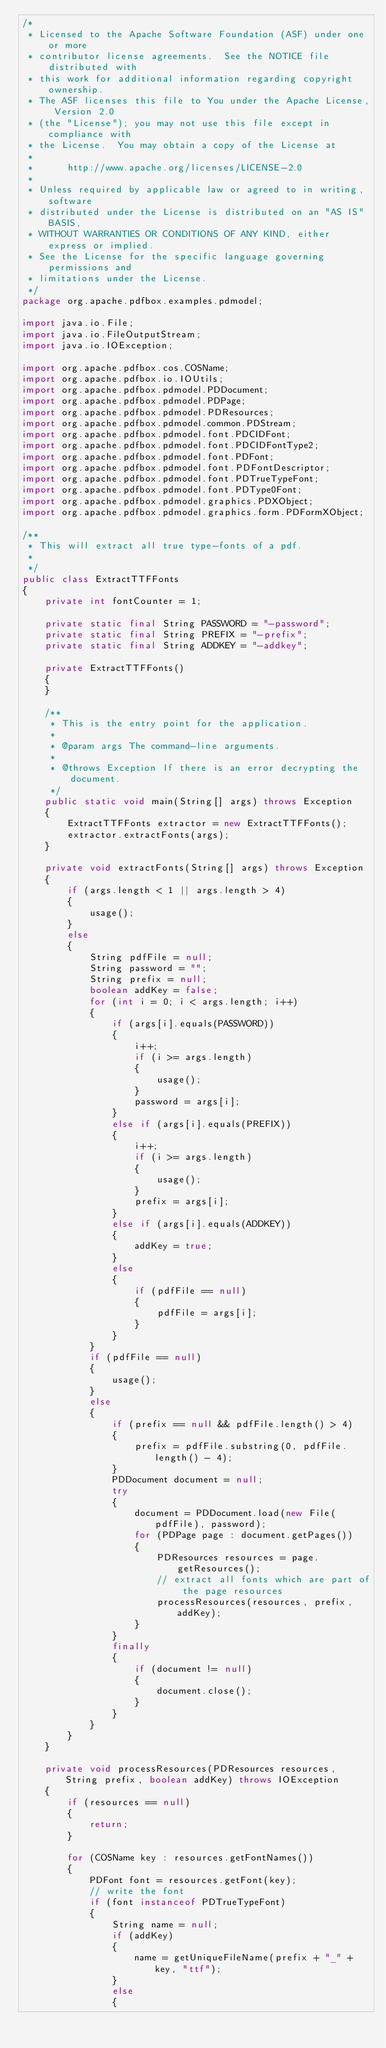Convert code to text. <code><loc_0><loc_0><loc_500><loc_500><_Java_>/*
 * Licensed to the Apache Software Foundation (ASF) under one or more
 * contributor license agreements.  See the NOTICE file distributed with
 * this work for additional information regarding copyright ownership.
 * The ASF licenses this file to You under the Apache License, Version 2.0
 * (the "License"); you may not use this file except in compliance with
 * the License.  You may obtain a copy of the License at
 *
 *      http://www.apache.org/licenses/LICENSE-2.0
 *
 * Unless required by applicable law or agreed to in writing, software
 * distributed under the License is distributed on an "AS IS" BASIS,
 * WITHOUT WARRANTIES OR CONDITIONS OF ANY KIND, either express or implied.
 * See the License for the specific language governing permissions and
 * limitations under the License.
 */
package org.apache.pdfbox.examples.pdmodel;

import java.io.File;
import java.io.FileOutputStream;
import java.io.IOException;

import org.apache.pdfbox.cos.COSName;
import org.apache.pdfbox.io.IOUtils;
import org.apache.pdfbox.pdmodel.PDDocument;
import org.apache.pdfbox.pdmodel.PDPage;
import org.apache.pdfbox.pdmodel.PDResources;
import org.apache.pdfbox.pdmodel.common.PDStream;
import org.apache.pdfbox.pdmodel.font.PDCIDFont;
import org.apache.pdfbox.pdmodel.font.PDCIDFontType2;
import org.apache.pdfbox.pdmodel.font.PDFont;
import org.apache.pdfbox.pdmodel.font.PDFontDescriptor;
import org.apache.pdfbox.pdmodel.font.PDTrueTypeFont;
import org.apache.pdfbox.pdmodel.font.PDType0Font;
import org.apache.pdfbox.pdmodel.graphics.PDXObject;
import org.apache.pdfbox.pdmodel.graphics.form.PDFormXObject;

/**
 * This will extract all true type-fonts of a pdf.
 * 
 */
public class ExtractTTFFonts
{
    private int fontCounter = 1;

    private static final String PASSWORD = "-password";
    private static final String PREFIX = "-prefix";
    private static final String ADDKEY = "-addkey";

    private ExtractTTFFonts()
    {
    }

    /**
     * This is the entry point for the application.
     * 
     * @param args The command-line arguments.
     * 
     * @throws Exception If there is an error decrypting the document.
     */
    public static void main(String[] args) throws Exception
    {
        ExtractTTFFonts extractor = new ExtractTTFFonts();
        extractor.extractFonts(args);
    }

    private void extractFonts(String[] args) throws Exception
    {
        if (args.length < 1 || args.length > 4)
        {
            usage();
        }
        else
        {
            String pdfFile = null;
            String password = "";
            String prefix = null;
            boolean addKey = false;
            for (int i = 0; i < args.length; i++)
            {
                if (args[i].equals(PASSWORD))
                {
                    i++;
                    if (i >= args.length)
                    {
                        usage();
                    }
                    password = args[i];
                }
                else if (args[i].equals(PREFIX))
                {
                    i++;
                    if (i >= args.length)
                    {
                        usage();
                    }
                    prefix = args[i];
                }
                else if (args[i].equals(ADDKEY))
                {
                    addKey = true;
                }
                else
                {
                    if (pdfFile == null)
                    {
                        pdfFile = args[i];
                    }
                }
            }
            if (pdfFile == null)
            {
                usage();
            }
            else
            {
                if (prefix == null && pdfFile.length() > 4)
                {
                    prefix = pdfFile.substring(0, pdfFile.length() - 4);
                }
                PDDocument document = null;
                try
                {
                    document = PDDocument.load(new File(pdfFile), password);
                    for (PDPage page : document.getPages())
                    {
                        PDResources resources = page.getResources();
                        // extract all fonts which are part of the page resources
                        processResources(resources, prefix, addKey);
                    }
                }
                finally
                {
                    if (document != null)
                    {
                        document.close();
                    }
                }
            }
        }
    }

    private void processResources(PDResources resources, String prefix, boolean addKey) throws IOException
    {
        if (resources == null)
        {
            return;
        }

        for (COSName key : resources.getFontNames())
        {
            PDFont font = resources.getFont(key);
            // write the font
            if (font instanceof PDTrueTypeFont)
            {
                String name = null;
                if (addKey)
                {
                    name = getUniqueFileName(prefix + "_" + key, "ttf");
                }
                else
                {</code> 